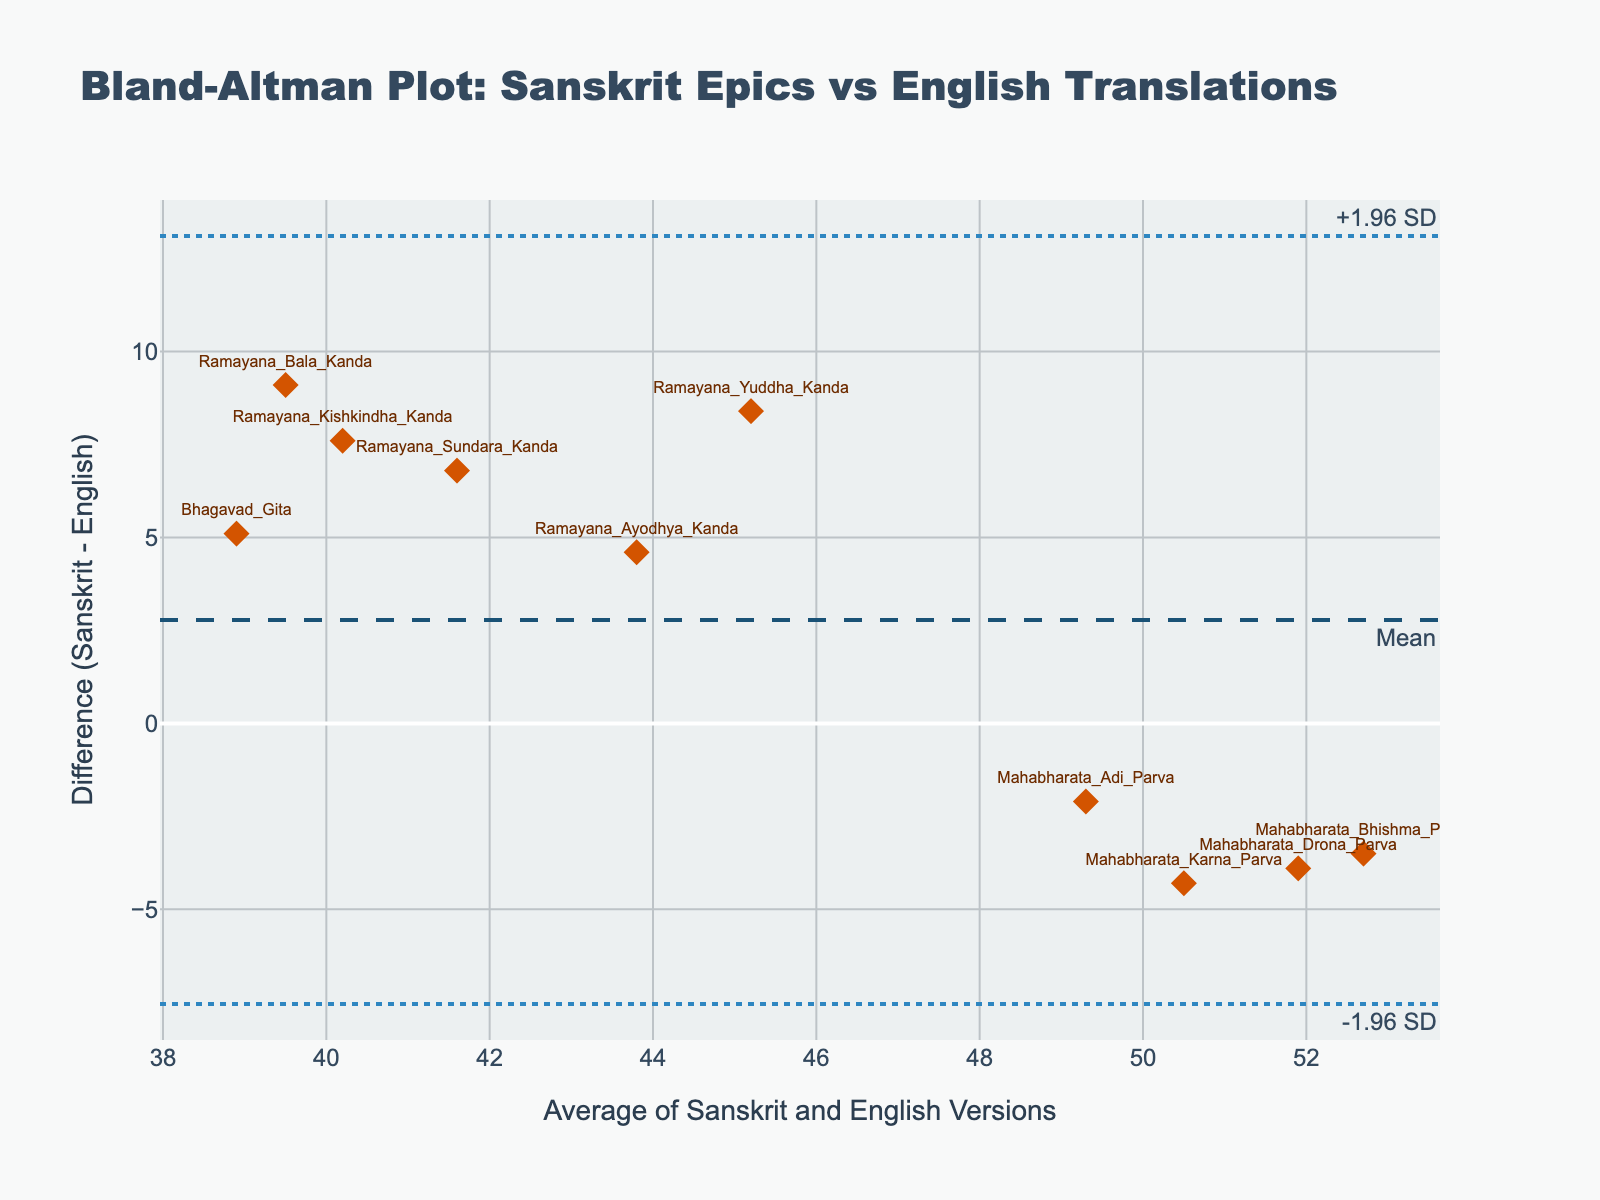what is the title of the plot? The title of the plot is typically displayed prominently at the top of the figure. In this case, the title given in the data is "Bland-Altman Plot: Sanskrit Epics vs English Translations".
Answer: Bland-Altman Plot: Sanskrit Epics vs English Translations How many data points are plotted in the figure? We need to count the number of entries in the dataset; each entry represents a data point. There are 10 data points corresponding to the 10 pairs of Sanskrit epics and their English translations.
Answer: 10 What does the y-axis represent in this plot? The y-axis in a Bland-Altman plot represents the difference between the paired measurements. Here, it signifies the difference in dialogue complexity between the Sanskrit epics and their English translations.
Answer: Difference in dialogue complexity What is the mean difference between the Sanskrit epics and their English translations? The mean difference line is usually highlighted with a specific annotation ("Mean") on the plot. According to the code, the mean difference is represented by this horizontal line.
Answer: The mean difference is marked on the plot as a dashed line Which Sanskrit epic has the largest positive difference in dialogue complexity from its English translation? By examining the data points and their y-axis values, we can find the entry with the highest positive value on the y-axis. The "Ramayana_Bala_Kanda" has a difference of 9.1, the largest positive difference.
Answer: Ramayana_Bala_Kanda Which data points fall outside the ±1.96 SD lines? Data points beyond the ±1.96 SD lines are exceptional in their differences. From the data or figure, we compare each difference with the plotted horizontal lines to identify any outliers. No points seem to fall outside the ±1.96 SD lines.
Answer: None What are the upper and lower limits of the ±1.96 standard deviation lines on the y-axis? The upper limit is calculated as the mean difference plus 1.96 times the standard deviation and the lower limit as the mean difference minus 1.96 times the standard deviation. These values are visualized as horizontal dotted lines.
Answer: mean_difference + 1.96*std_diff and mean_difference - 1.96*std_diff Which Sanskrit epic has the smallest difference in dialogue complexity from its English translation? To find the smallest difference, we look at the closest point to the y-axis value of zero. The "Mahabharata_Adi_Parva" with a difference of -2.1 has the smallest differential.
Answer: Mahabharata_Adi_Parva Are there more Sanskrit epics with positive differences or negative differences? By counting the data points above and below the zero difference line on the y-axis, we can determine which is more prevalent. There are more positive differences as we observe the data points above the zero line.
Answer: More positive differences 